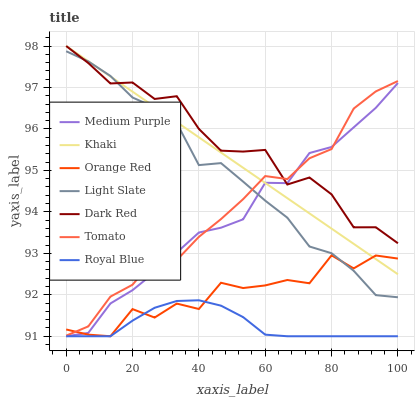Does Royal Blue have the minimum area under the curve?
Answer yes or no. Yes. Does Dark Red have the maximum area under the curve?
Answer yes or no. Yes. Does Khaki have the minimum area under the curve?
Answer yes or no. No. Does Khaki have the maximum area under the curve?
Answer yes or no. No. Is Khaki the smoothest?
Answer yes or no. Yes. Is Orange Red the roughest?
Answer yes or no. Yes. Is Light Slate the smoothest?
Answer yes or no. No. Is Light Slate the roughest?
Answer yes or no. No. Does Medium Purple have the lowest value?
Answer yes or no. Yes. Does Khaki have the lowest value?
Answer yes or no. No. Does Dark Red have the highest value?
Answer yes or no. Yes. Does Light Slate have the highest value?
Answer yes or no. No. Is Royal Blue less than Khaki?
Answer yes or no. Yes. Is Dark Red greater than Royal Blue?
Answer yes or no. Yes. Does Royal Blue intersect Orange Red?
Answer yes or no. Yes. Is Royal Blue less than Orange Red?
Answer yes or no. No. Is Royal Blue greater than Orange Red?
Answer yes or no. No. Does Royal Blue intersect Khaki?
Answer yes or no. No. 